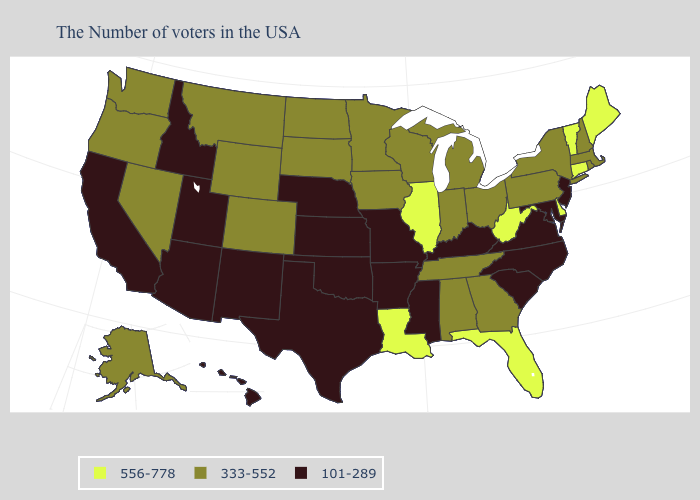What is the value of Wisconsin?
Concise answer only. 333-552. Name the states that have a value in the range 333-552?
Quick response, please. Massachusetts, Rhode Island, New Hampshire, New York, Pennsylvania, Ohio, Georgia, Michigan, Indiana, Alabama, Tennessee, Wisconsin, Minnesota, Iowa, South Dakota, North Dakota, Wyoming, Colorado, Montana, Nevada, Washington, Oregon, Alaska. What is the highest value in the USA?
Quick response, please. 556-778. Among the states that border Washington , does Oregon have the lowest value?
Quick response, please. No. Which states hav the highest value in the MidWest?
Answer briefly. Illinois. Does New Jersey have the lowest value in the Northeast?
Short answer required. Yes. Which states have the highest value in the USA?
Answer briefly. Maine, Vermont, Connecticut, Delaware, West Virginia, Florida, Illinois, Louisiana. What is the highest value in the West ?
Give a very brief answer. 333-552. What is the value of Mississippi?
Be succinct. 101-289. What is the value of Maryland?
Write a very short answer. 101-289. Which states hav the highest value in the MidWest?
Give a very brief answer. Illinois. What is the value of South Carolina?
Concise answer only. 101-289. Which states hav the highest value in the West?
Keep it brief. Wyoming, Colorado, Montana, Nevada, Washington, Oregon, Alaska. Name the states that have a value in the range 101-289?
Quick response, please. New Jersey, Maryland, Virginia, North Carolina, South Carolina, Kentucky, Mississippi, Missouri, Arkansas, Kansas, Nebraska, Oklahoma, Texas, New Mexico, Utah, Arizona, Idaho, California, Hawaii. 